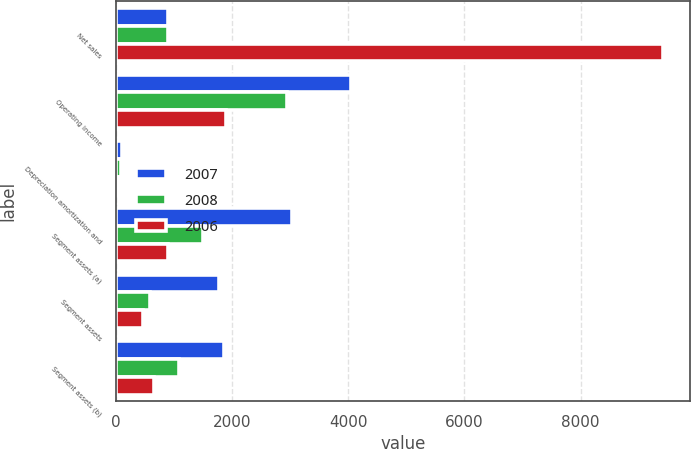Convert chart to OTSL. <chart><loc_0><loc_0><loc_500><loc_500><stacked_bar_chart><ecel><fcel>Net sales<fcel>Operating income<fcel>Depreciation amortization and<fcel>Segment assets (a)<fcel>Segment assets<fcel>Segment assets (b)<nl><fcel>2007<fcel>896<fcel>4051<fcel>108<fcel>3039<fcel>1775<fcel>1869<nl><fcel>2008<fcel>896<fcel>2949<fcel>88<fcel>1497<fcel>595<fcel>1085<nl><fcel>2006<fcel>9415<fcel>1899<fcel>59<fcel>896<fcel>471<fcel>651<nl></chart> 